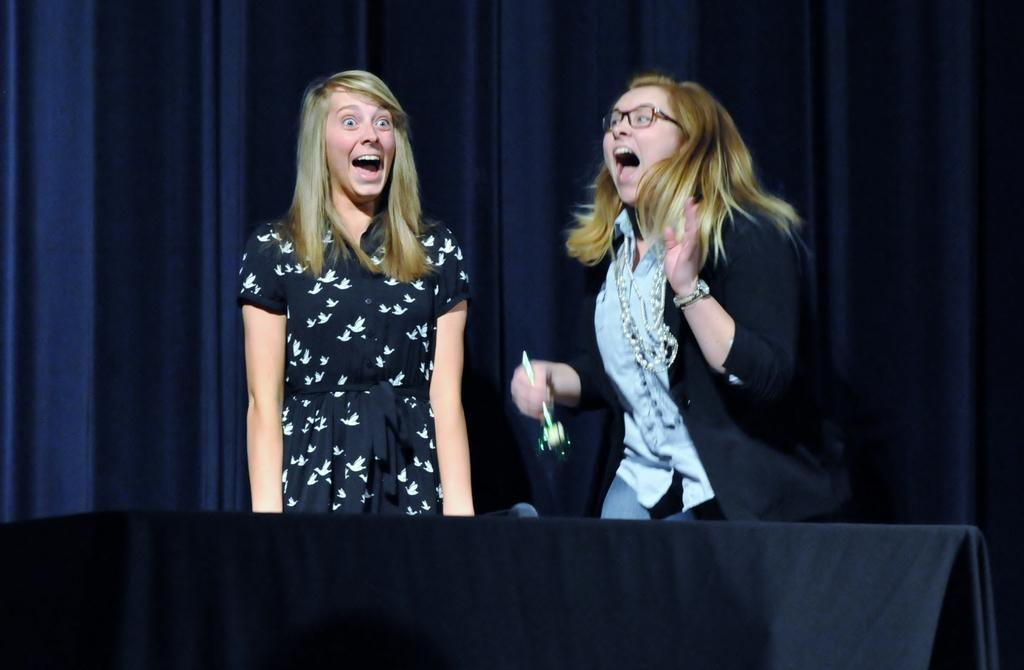How many people are in the image? There are two women in the image. What are the women doing in the image? The women are laughing. What is the person on the right side holding in her hand? The right side person is holding an object in her hand. What type of window treatment is visible in the image? There are curtains visible in the image. What type of bottle can be seen floating in the air in the image? There is no bottle present in the image, and nothing is floating in the air. 